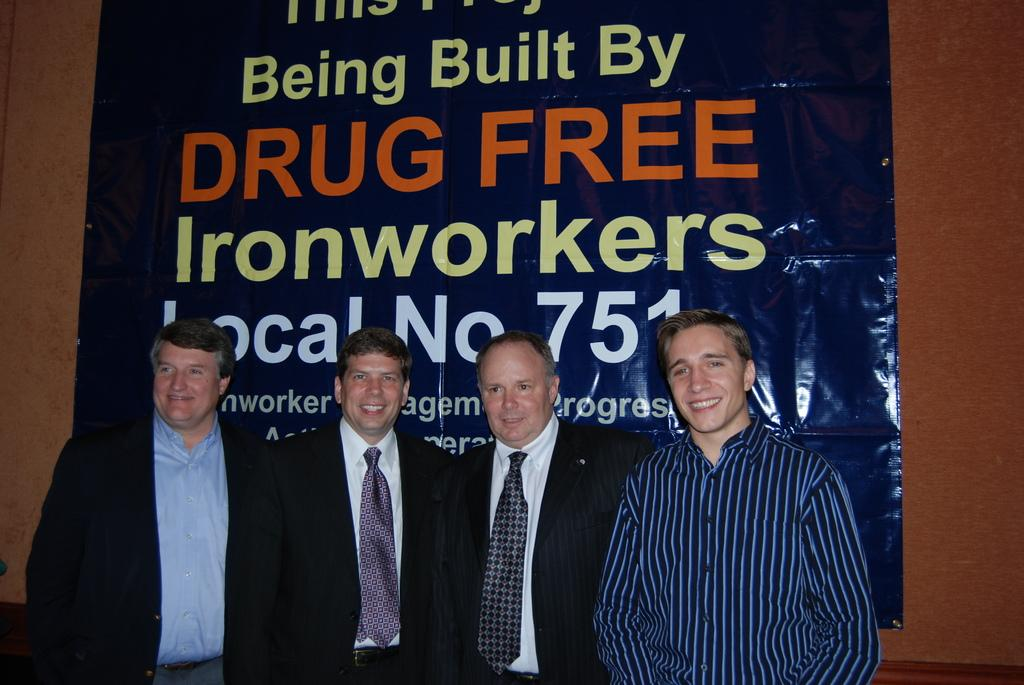What are the people in the image doing? The persons in the center of the image are standing and smiling. What type of clothing can be seen on some of the persons? Some of the persons are wearing a suit and tie. What can be seen in the background of the image? There is a wall and a banner in the background of the image. What type of leaf can be seen falling from the banner in the image? There is no leaf present in the image, and the banner does not depict any falling leaves. What color is the chalk used to write on the wall in the image? There is no chalk or writing on the wall in the image. 